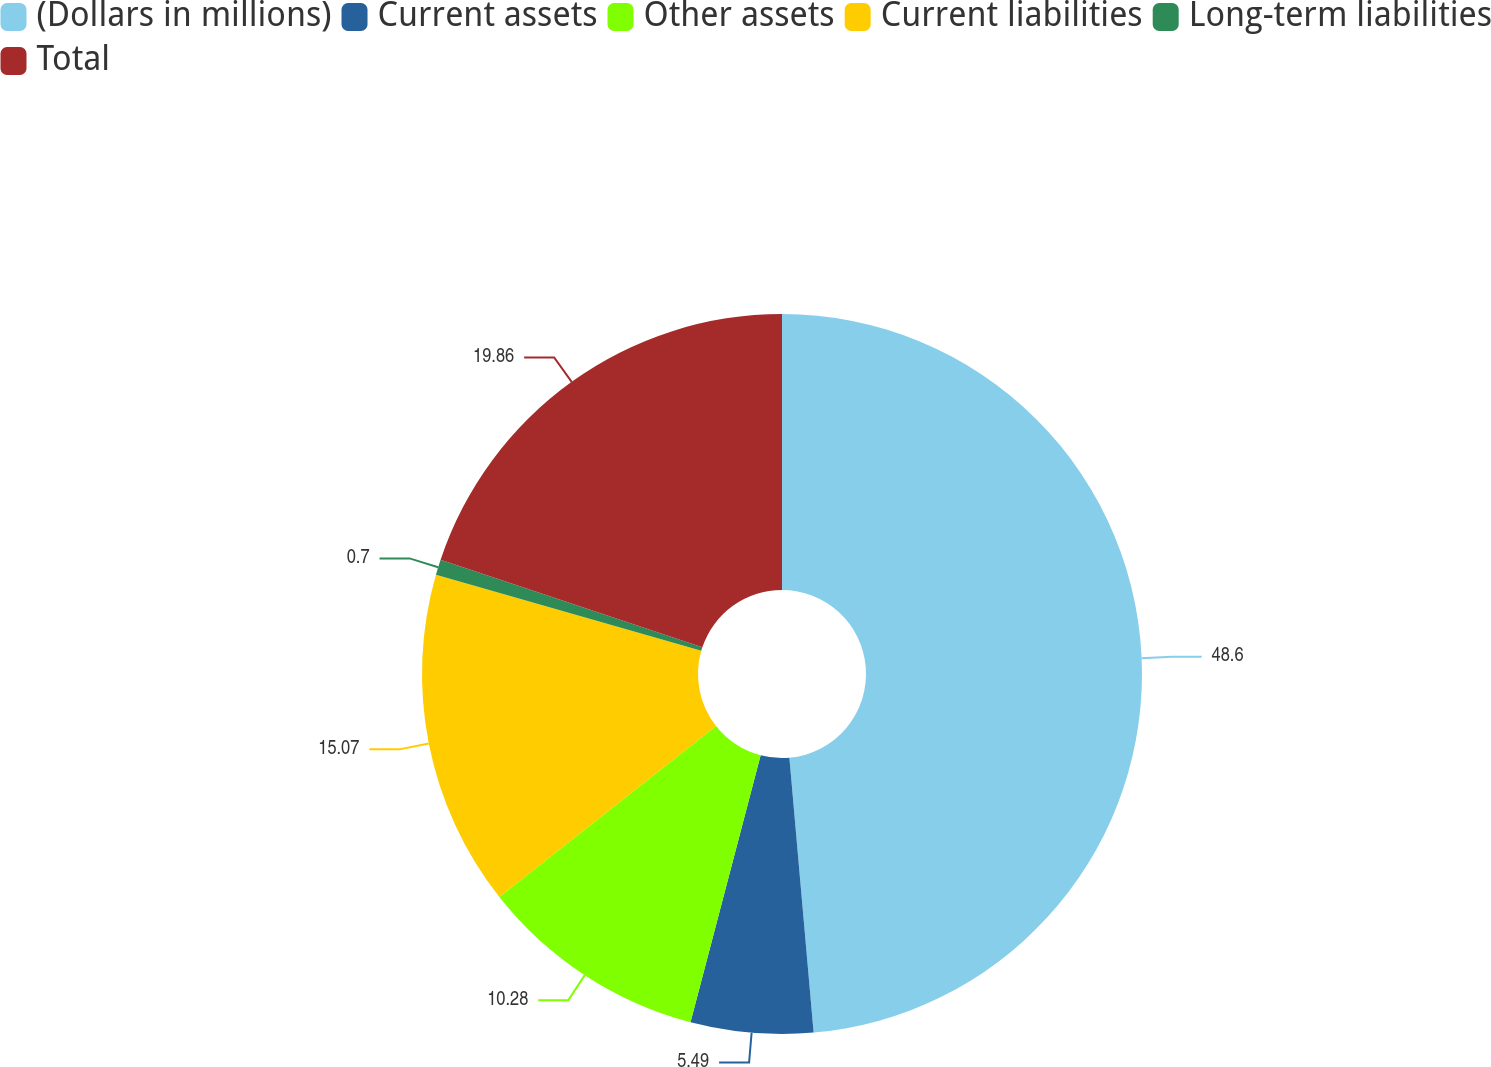Convert chart. <chart><loc_0><loc_0><loc_500><loc_500><pie_chart><fcel>(Dollars in millions)<fcel>Current assets<fcel>Other assets<fcel>Current liabilities<fcel>Long-term liabilities<fcel>Total<nl><fcel>48.6%<fcel>5.49%<fcel>10.28%<fcel>15.07%<fcel>0.7%<fcel>19.86%<nl></chart> 